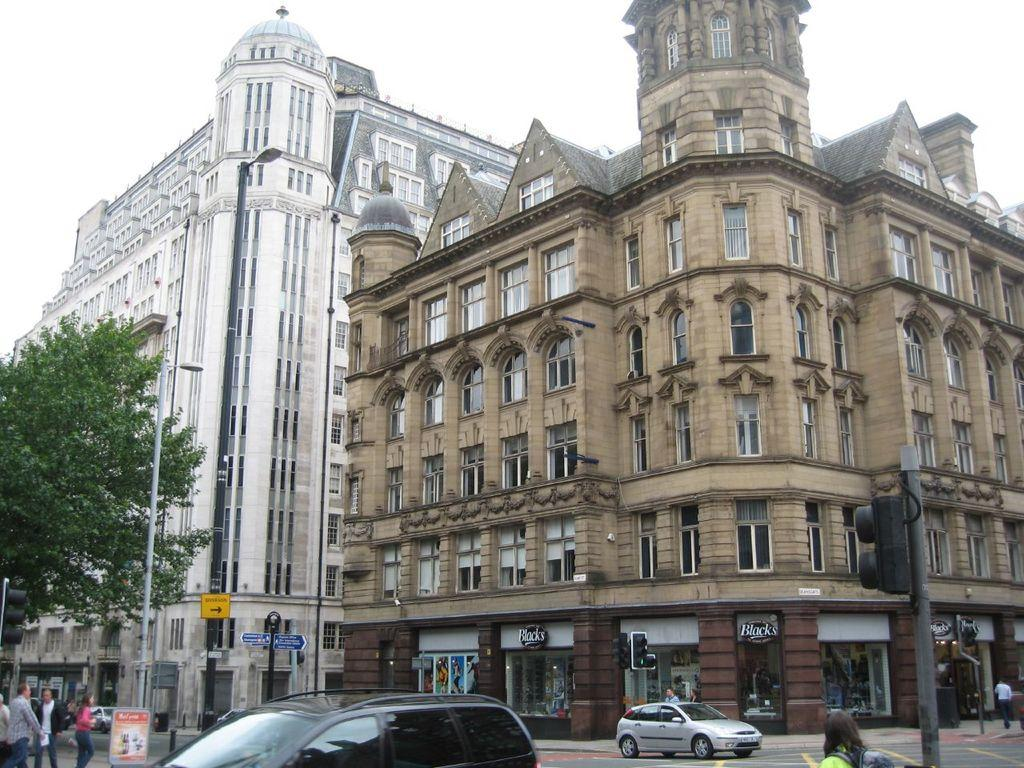What can be seen on the road in the image? There are vehicles and people on the road in the image. What is used to control traffic flow in the image? There is a traffic signal on the road in the image. What other objects can be seen on the road? There are sign boards and poles on the road in the image. What is present at the left side of the image? There is a tree at the left side of the image. What can be seen in the background of the image? There are buildings visible in the background of the image. How does the wind affect the waves in the image? There are no waves or wind present in the image; it features a road with vehicles, people, and other objects. What year is depicted in the image? The image does not depict a specific year; it is a snapshot of a scene at a particular moment in time. 